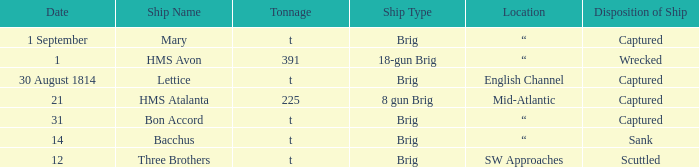For the ship that was a brig and located in the English Channel, what was the disposition of ship? Captured. 